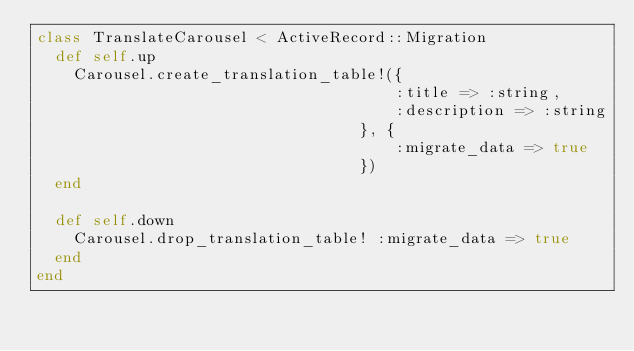Convert code to text. <code><loc_0><loc_0><loc_500><loc_500><_Ruby_>class TranslateCarousel < ActiveRecord::Migration
  def self.up
    Carousel.create_translation_table!({
                                       :title => :string,
                                       :description => :string
                                   }, {
                                       :migrate_data => true
                                   })
  end

  def self.down
    Carousel.drop_translation_table! :migrate_data => true
  end
end
</code> 